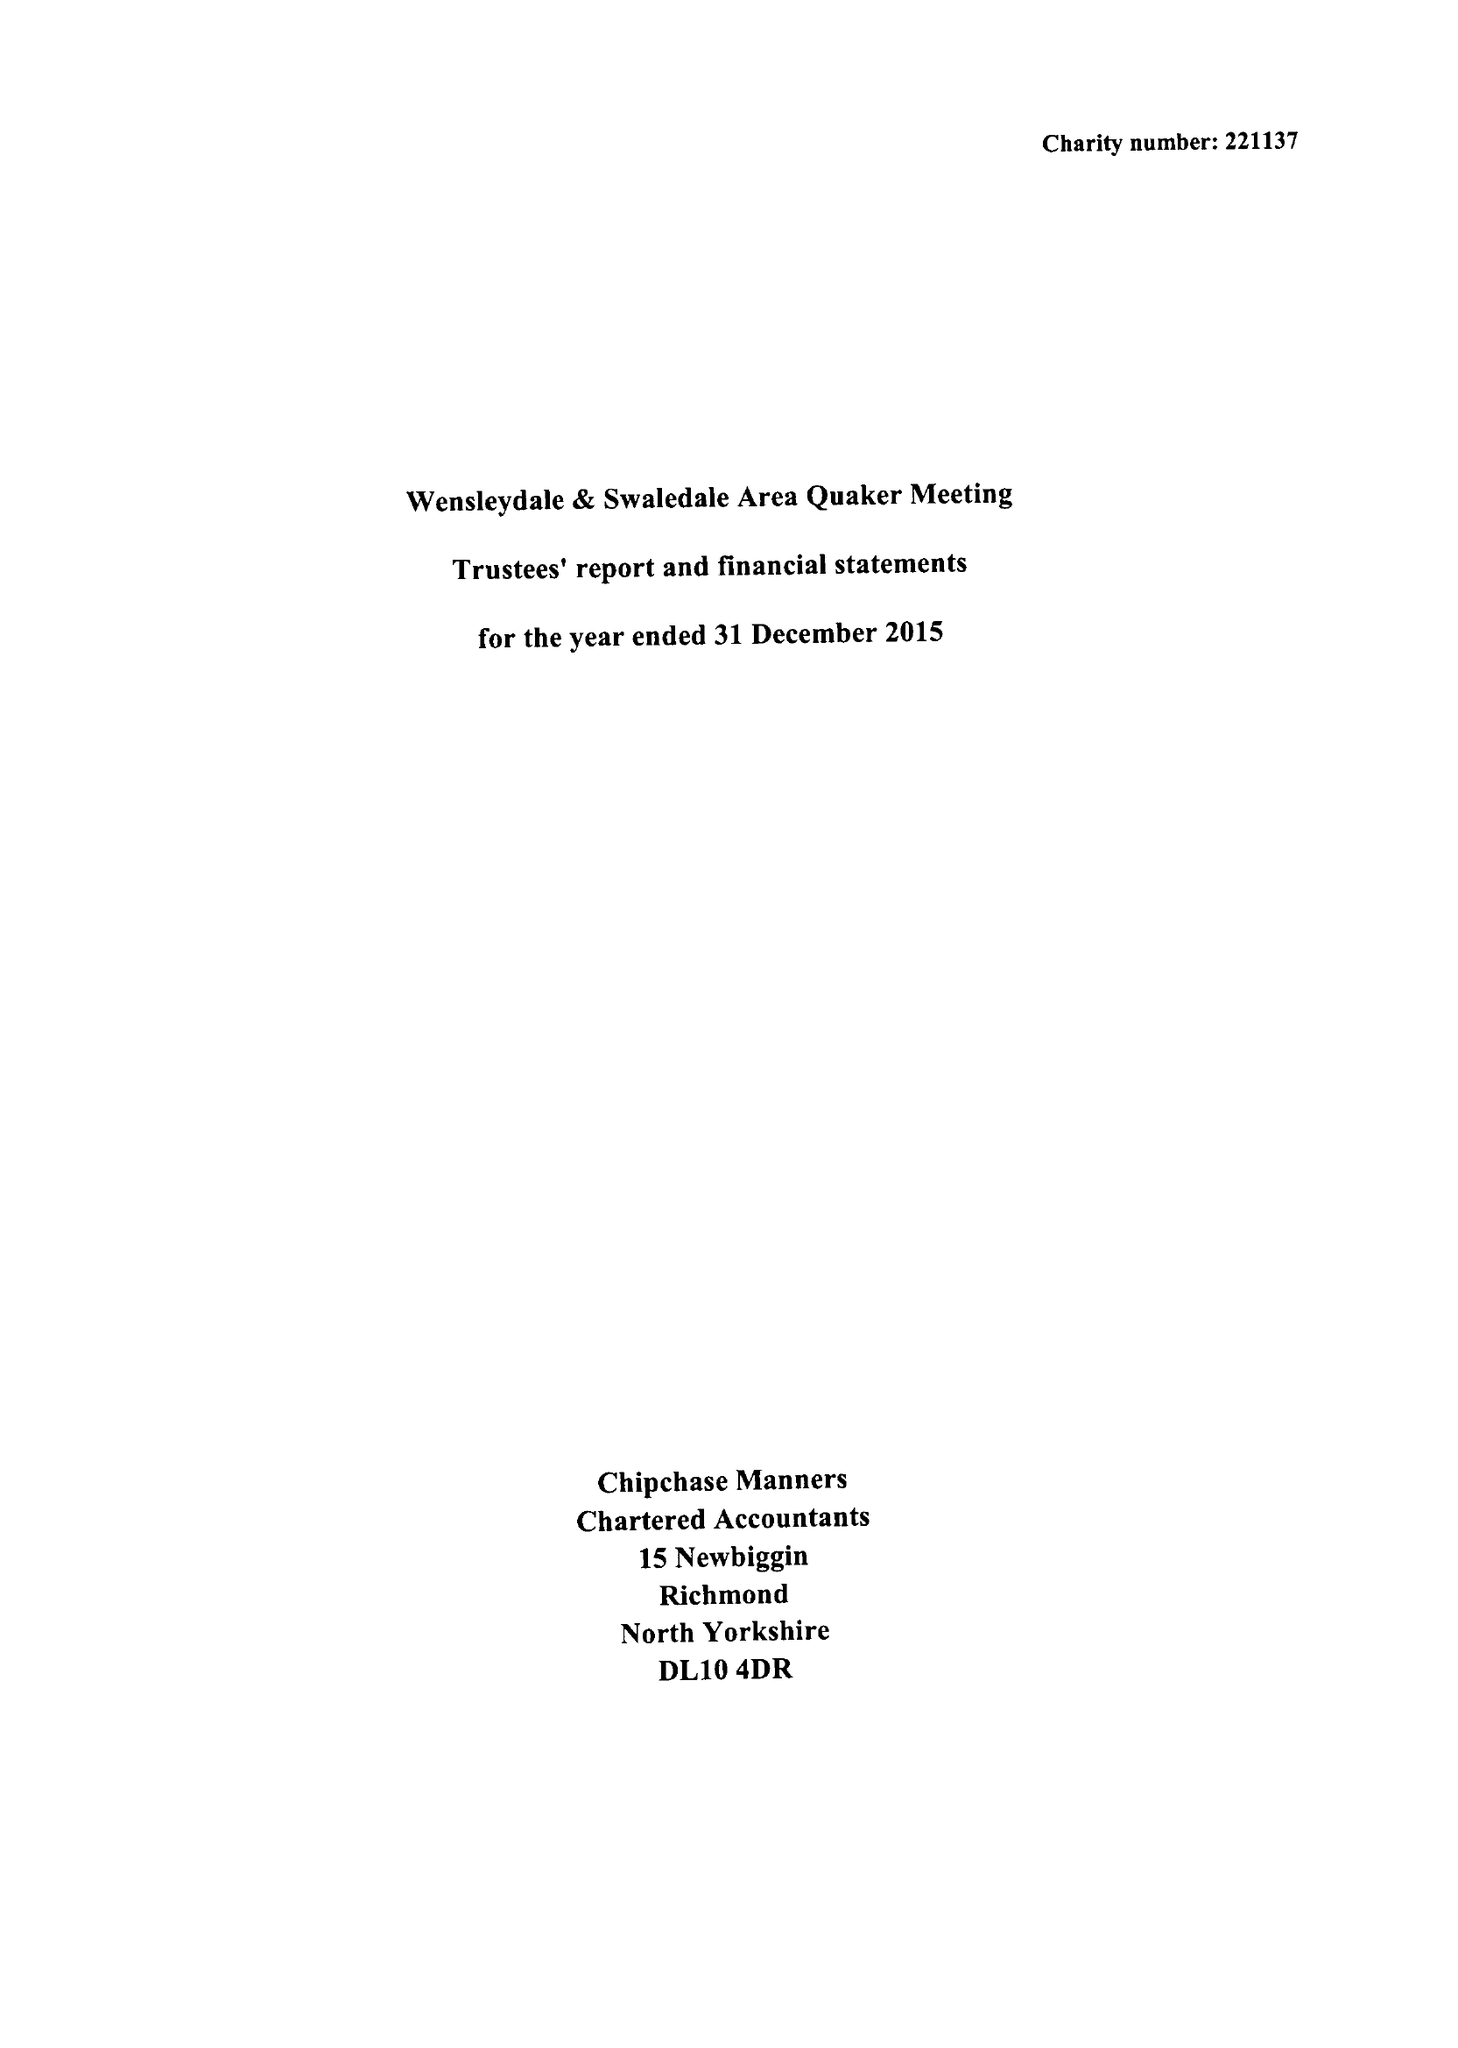What is the value for the report_date?
Answer the question using a single word or phrase. 2015-12-31 